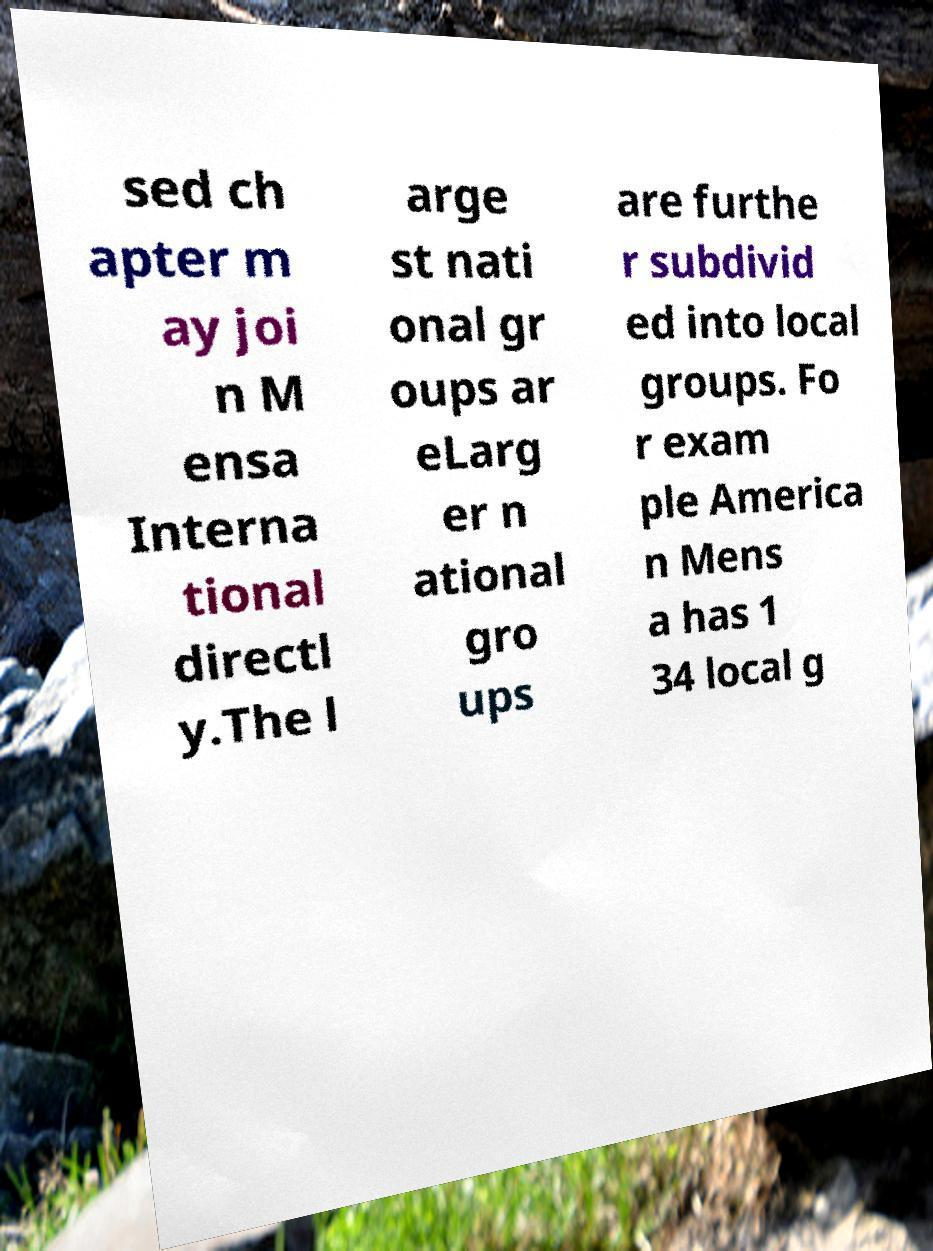What messages or text are displayed in this image? I need them in a readable, typed format. sed ch apter m ay joi n M ensa Interna tional directl y.The l arge st nati onal gr oups ar eLarg er n ational gro ups are furthe r subdivid ed into local groups. Fo r exam ple America n Mens a has 1 34 local g 